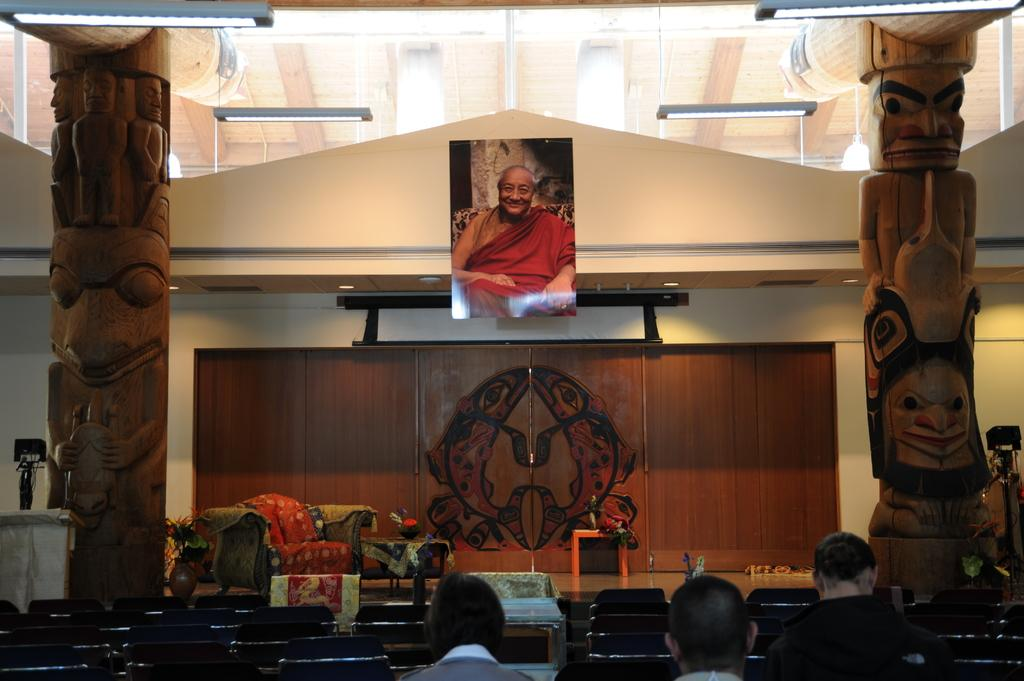How many people are sitting in the image? There are three people sitting in the image. What is in front of the people? There is a couch and a teapoy in front of the people. What other objects can be seen in the image? There are additional objects visible in the image, including a photo and lights at the top. What might be used for holding or displaying items in the image? The teapoy in front of the people might be used for holding or displaying items. What type of grain is being harvested in the image? There is no grain or harvesting activity present in the image. What rhythm is being played by the people in the image? There is no music or rhythm being played by the people in the image. 